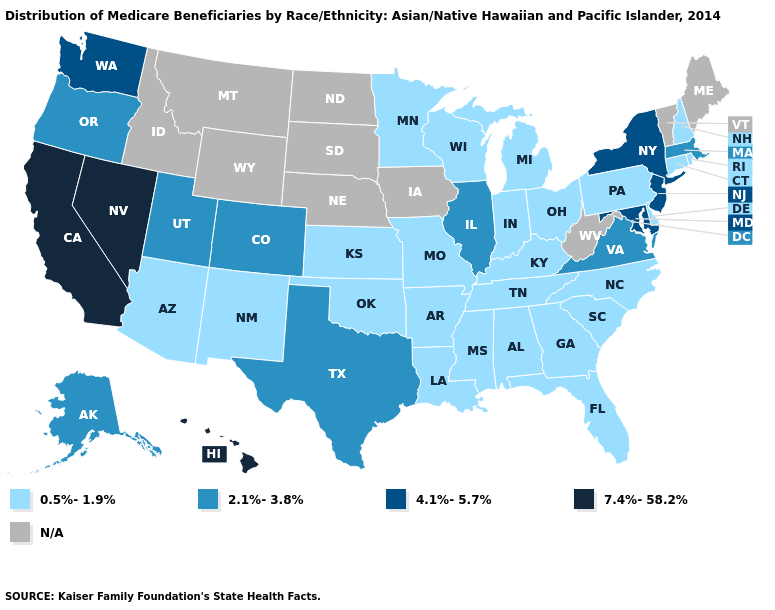Name the states that have a value in the range 0.5%-1.9%?
Answer briefly. Alabama, Arizona, Arkansas, Connecticut, Delaware, Florida, Georgia, Indiana, Kansas, Kentucky, Louisiana, Michigan, Minnesota, Mississippi, Missouri, New Hampshire, New Mexico, North Carolina, Ohio, Oklahoma, Pennsylvania, Rhode Island, South Carolina, Tennessee, Wisconsin. What is the value of Nevada?
Quick response, please. 7.4%-58.2%. Which states have the lowest value in the USA?
Answer briefly. Alabama, Arizona, Arkansas, Connecticut, Delaware, Florida, Georgia, Indiana, Kansas, Kentucky, Louisiana, Michigan, Minnesota, Mississippi, Missouri, New Hampshire, New Mexico, North Carolina, Ohio, Oklahoma, Pennsylvania, Rhode Island, South Carolina, Tennessee, Wisconsin. Does the first symbol in the legend represent the smallest category?
Answer briefly. Yes. Among the states that border New Hampshire , which have the lowest value?
Give a very brief answer. Massachusetts. Name the states that have a value in the range 7.4%-58.2%?
Keep it brief. California, Hawaii, Nevada. Does the map have missing data?
Answer briefly. Yes. Name the states that have a value in the range 2.1%-3.8%?
Concise answer only. Alaska, Colorado, Illinois, Massachusetts, Oregon, Texas, Utah, Virginia. What is the value of Colorado?
Short answer required. 2.1%-3.8%. What is the value of Alaska?
Quick response, please. 2.1%-3.8%. What is the highest value in states that border Iowa?
Keep it brief. 2.1%-3.8%. Which states hav the highest value in the West?
Short answer required. California, Hawaii, Nevada. What is the value of Florida?
Give a very brief answer. 0.5%-1.9%. What is the value of North Carolina?
Write a very short answer. 0.5%-1.9%. 